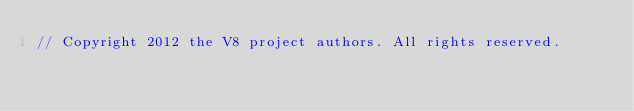<code> <loc_0><loc_0><loc_500><loc_500><_C++_>// Copyright 2012 the V8 project authors. All rights reserved.</code> 